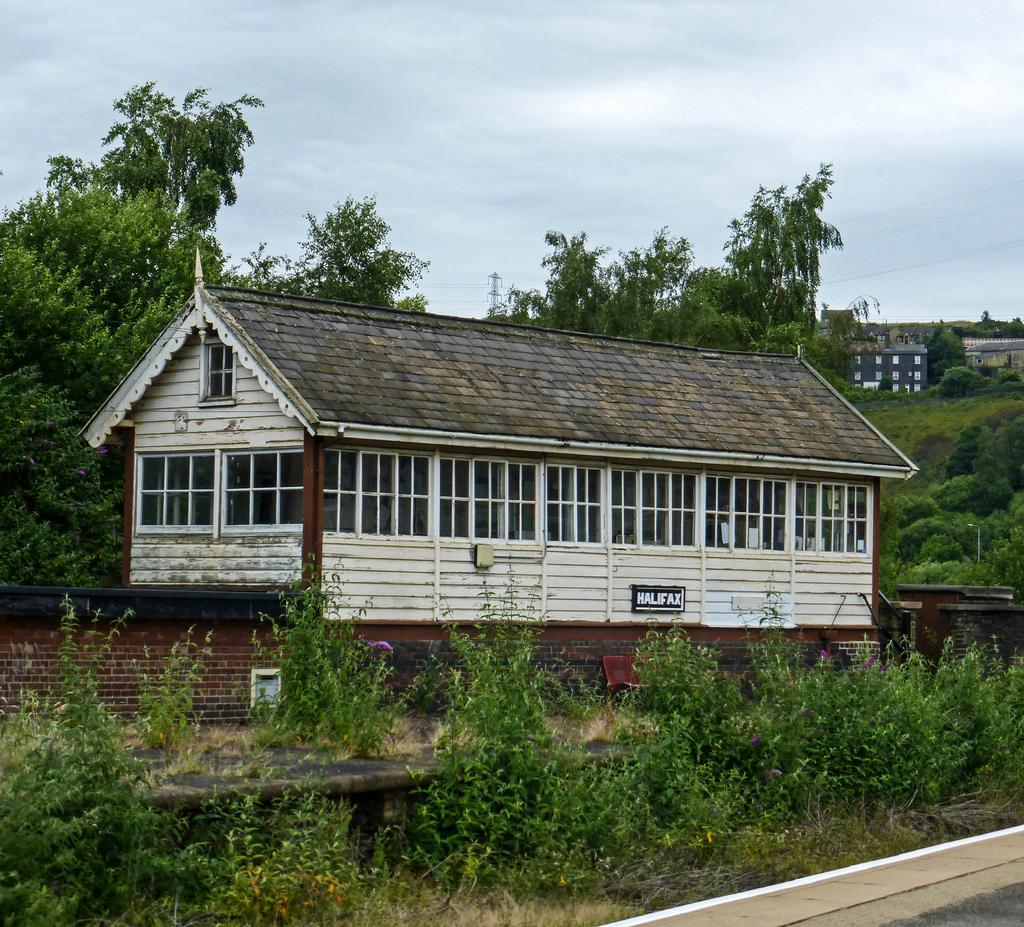What type of living organisms can be seen in the image? Plants and trees are visible in the image. What type of structure is present in the image? There is a brick wall and houses in the image. What else can be seen in the image besides plants and structures? There are wires and other objects visible in the image. What is visible in the sky in the image? The sky is visible in the image. What type of substance is being used by the flock of birds to maintain peace in the image? There are no birds or any mention of peace or a substance in the image. 